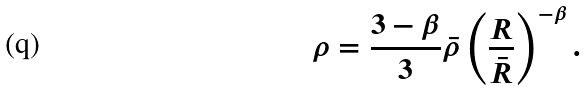<formula> <loc_0><loc_0><loc_500><loc_500>\rho = \frac { 3 - \beta } { 3 } \bar { \rho } \left ( \frac { R } { \bar { R } } \right ) ^ { - \beta } .</formula> 